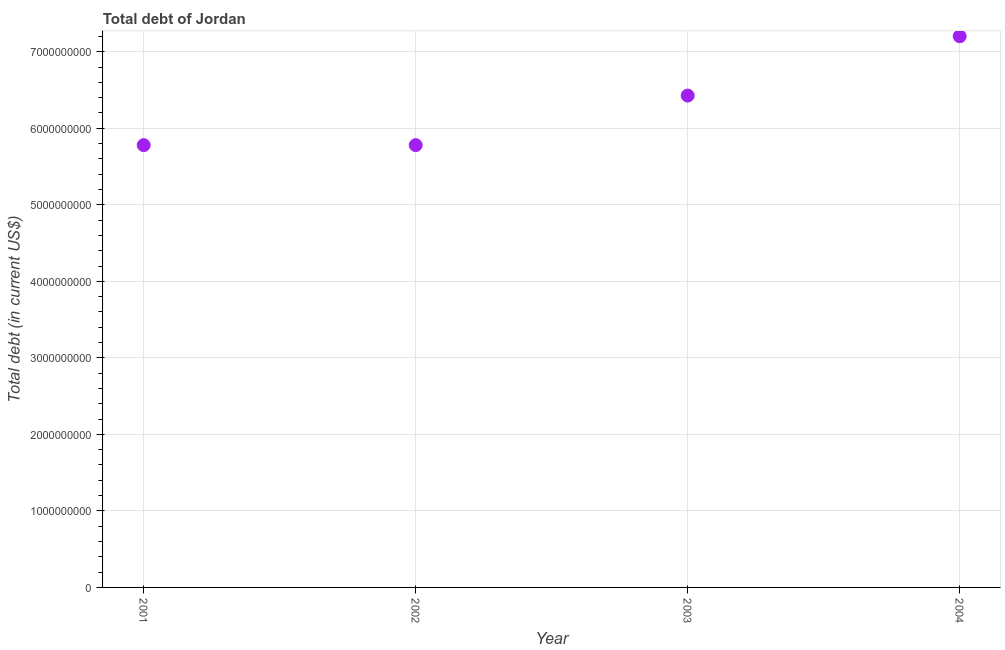What is the total debt in 2004?
Offer a very short reply. 7.20e+09. Across all years, what is the maximum total debt?
Ensure brevity in your answer.  7.20e+09. Across all years, what is the minimum total debt?
Your answer should be compact. 5.78e+09. In which year was the total debt minimum?
Give a very brief answer. 2001. What is the sum of the total debt?
Your answer should be compact. 2.52e+1. What is the difference between the total debt in 2003 and 2004?
Your response must be concise. -7.75e+08. What is the average total debt per year?
Your answer should be very brief. 6.30e+09. What is the median total debt?
Your answer should be very brief. 6.10e+09. What is the ratio of the total debt in 2003 to that in 2004?
Your response must be concise. 0.89. Is the total debt in 2002 less than that in 2003?
Keep it short and to the point. Yes. Is the difference between the total debt in 2001 and 2002 greater than the difference between any two years?
Provide a succinct answer. No. What is the difference between the highest and the second highest total debt?
Your response must be concise. 7.75e+08. What is the difference between the highest and the lowest total debt?
Provide a short and direct response. 1.42e+09. In how many years, is the total debt greater than the average total debt taken over all years?
Make the answer very short. 2. Does the total debt monotonically increase over the years?
Give a very brief answer. No. How many dotlines are there?
Ensure brevity in your answer.  1. What is the difference between two consecutive major ticks on the Y-axis?
Give a very brief answer. 1.00e+09. Are the values on the major ticks of Y-axis written in scientific E-notation?
Offer a terse response. No. Does the graph contain any zero values?
Provide a succinct answer. No. What is the title of the graph?
Your answer should be very brief. Total debt of Jordan. What is the label or title of the X-axis?
Offer a very short reply. Year. What is the label or title of the Y-axis?
Offer a terse response. Total debt (in current US$). What is the Total debt (in current US$) in 2001?
Offer a terse response. 5.78e+09. What is the Total debt (in current US$) in 2002?
Your response must be concise. 5.78e+09. What is the Total debt (in current US$) in 2003?
Your response must be concise. 6.43e+09. What is the Total debt (in current US$) in 2004?
Offer a very short reply. 7.20e+09. What is the difference between the Total debt (in current US$) in 2001 and 2003?
Offer a very short reply. -6.48e+08. What is the difference between the Total debt (in current US$) in 2001 and 2004?
Provide a succinct answer. -1.42e+09. What is the difference between the Total debt (in current US$) in 2002 and 2003?
Offer a terse response. -6.48e+08. What is the difference between the Total debt (in current US$) in 2002 and 2004?
Provide a short and direct response. -1.42e+09. What is the difference between the Total debt (in current US$) in 2003 and 2004?
Your response must be concise. -7.75e+08. What is the ratio of the Total debt (in current US$) in 2001 to that in 2002?
Make the answer very short. 1. What is the ratio of the Total debt (in current US$) in 2001 to that in 2003?
Provide a succinct answer. 0.9. What is the ratio of the Total debt (in current US$) in 2001 to that in 2004?
Provide a succinct answer. 0.8. What is the ratio of the Total debt (in current US$) in 2002 to that in 2003?
Make the answer very short. 0.9. What is the ratio of the Total debt (in current US$) in 2002 to that in 2004?
Give a very brief answer. 0.8. What is the ratio of the Total debt (in current US$) in 2003 to that in 2004?
Provide a short and direct response. 0.89. 